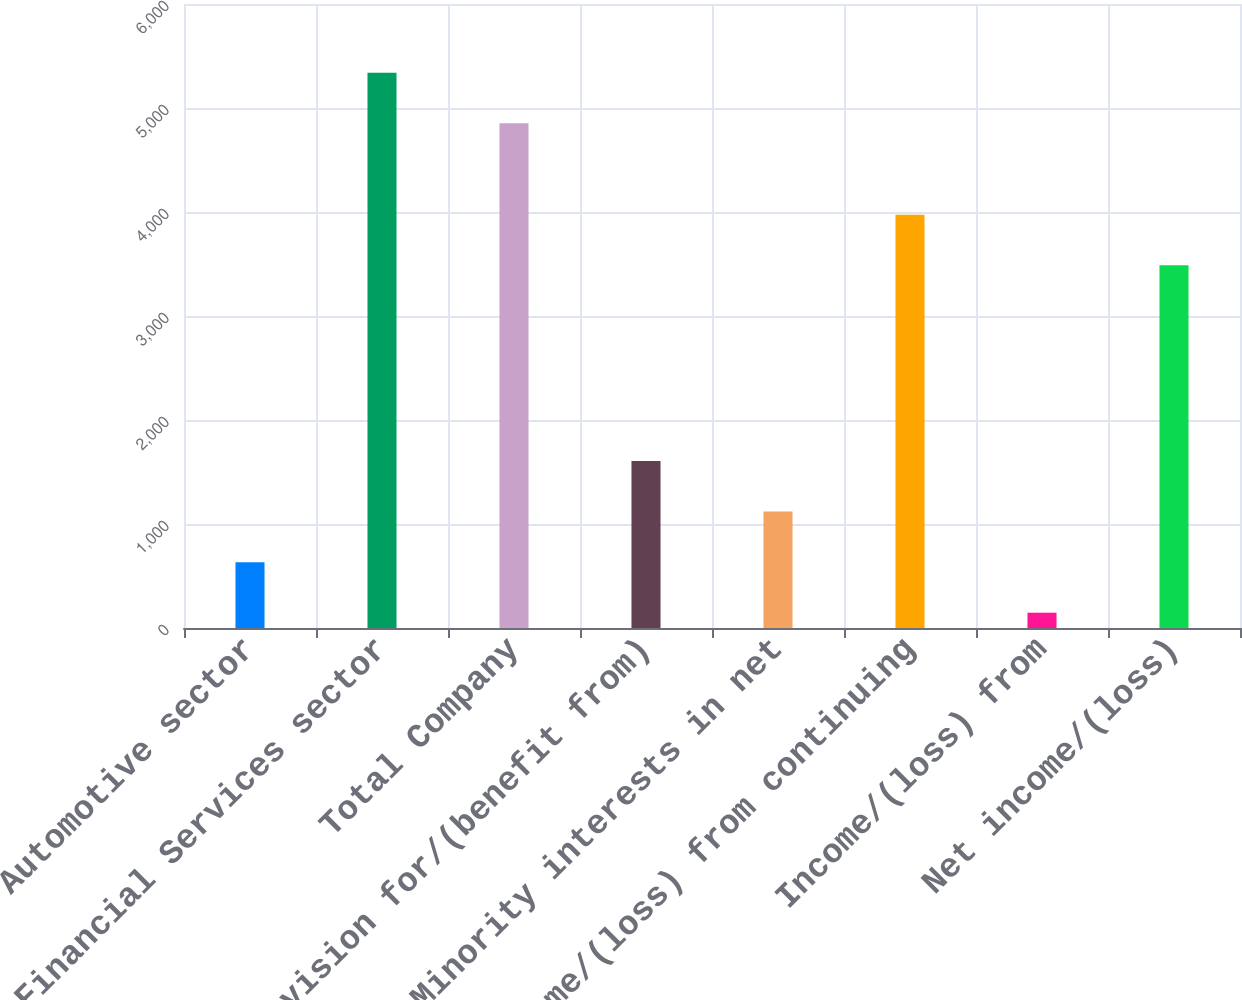Convert chart. <chart><loc_0><loc_0><loc_500><loc_500><bar_chart><fcel>Automotive sector<fcel>Financial Services sector<fcel>Total Company<fcel>Provision for/(benefit from)<fcel>Minority interests in net<fcel>Income/(loss) from continuing<fcel>Income/(loss) from<fcel>Net income/(loss)<nl><fcel>633.1<fcel>5339.1<fcel>4853<fcel>1605.3<fcel>1119.2<fcel>3973.1<fcel>147<fcel>3487<nl></chart> 